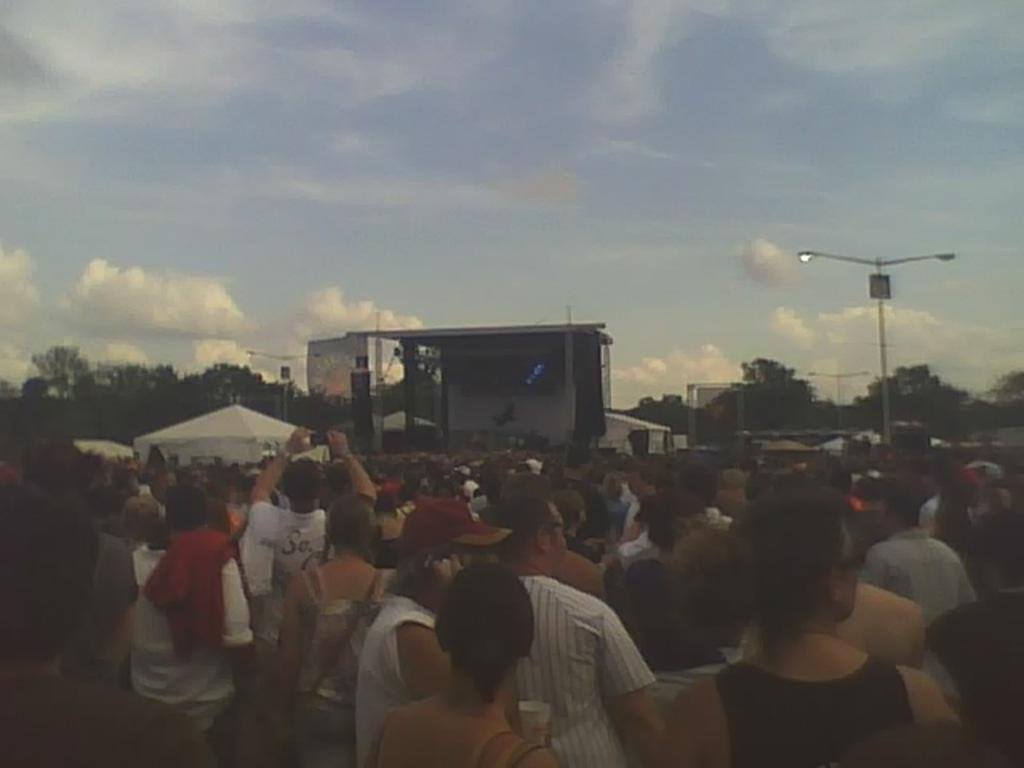How many people are in the image? There is a group of people in the image, but the exact number cannot be determined from the provided facts. What type of structures can be seen in the image? There are buildings in the image. What type of lighting is present in the image? Street lamps are present in the image. What type of vegetation is visible in the image? Trees are visible in the image. What is visible at the top of the image? The sky is visible at the top of the image, and there are clouds in the sky. How would you describe the lighting conditions in the image? The image appears to be slightly dark. What type of disgust can be seen on the faces of the people in the image? There is no indication of disgust on the faces of the people in the image. How many units of the bucket are visible in the image? There is no bucket present in the image. 